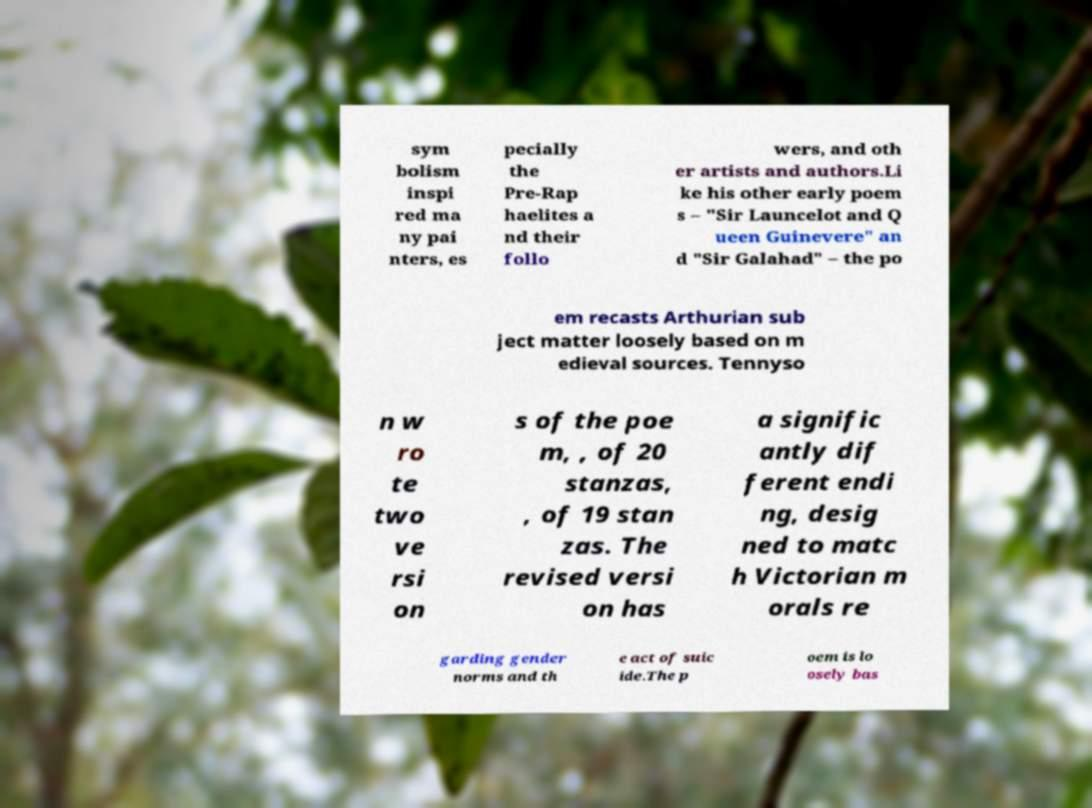Could you extract and type out the text from this image? sym bolism inspi red ma ny pai nters, es pecially the Pre-Rap haelites a nd their follo wers, and oth er artists and authors.Li ke his other early poem s – "Sir Launcelot and Q ueen Guinevere" an d "Sir Galahad" – the po em recasts Arthurian sub ject matter loosely based on m edieval sources. Tennyso n w ro te two ve rsi on s of the poe m, , of 20 stanzas, , of 19 stan zas. The revised versi on has a signific antly dif ferent endi ng, desig ned to matc h Victorian m orals re garding gender norms and th e act of suic ide.The p oem is lo osely bas 